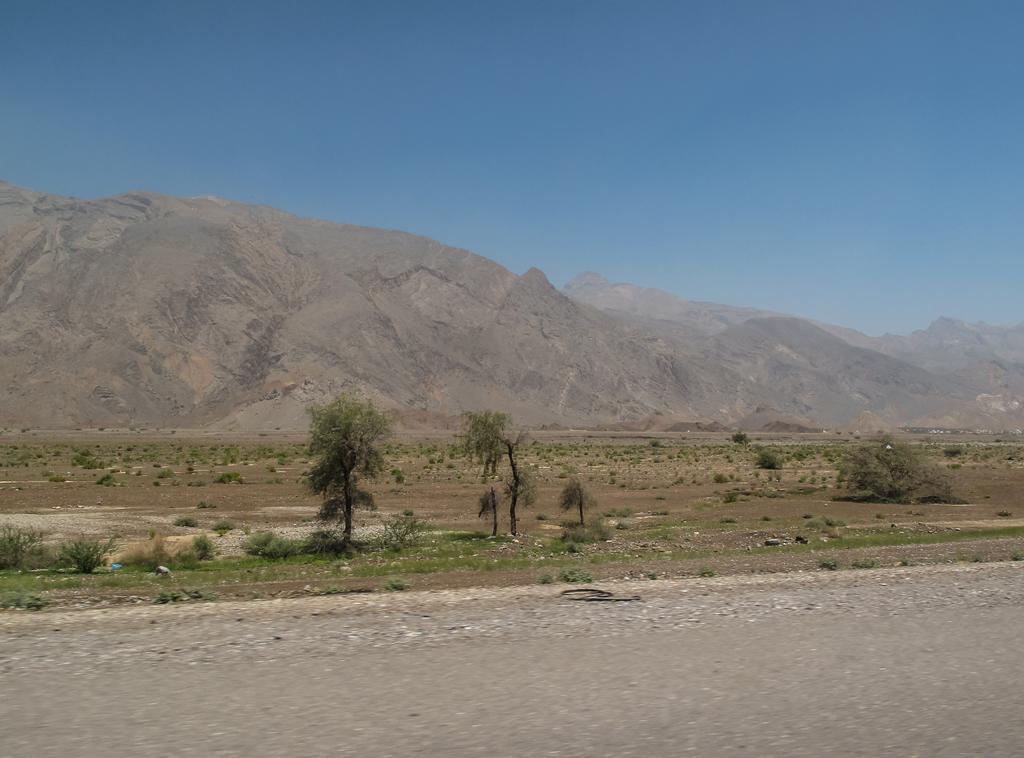In one or two sentences, can you explain what this image depicts? In this picture we can see few trees and plants, in the background we can find hills. 